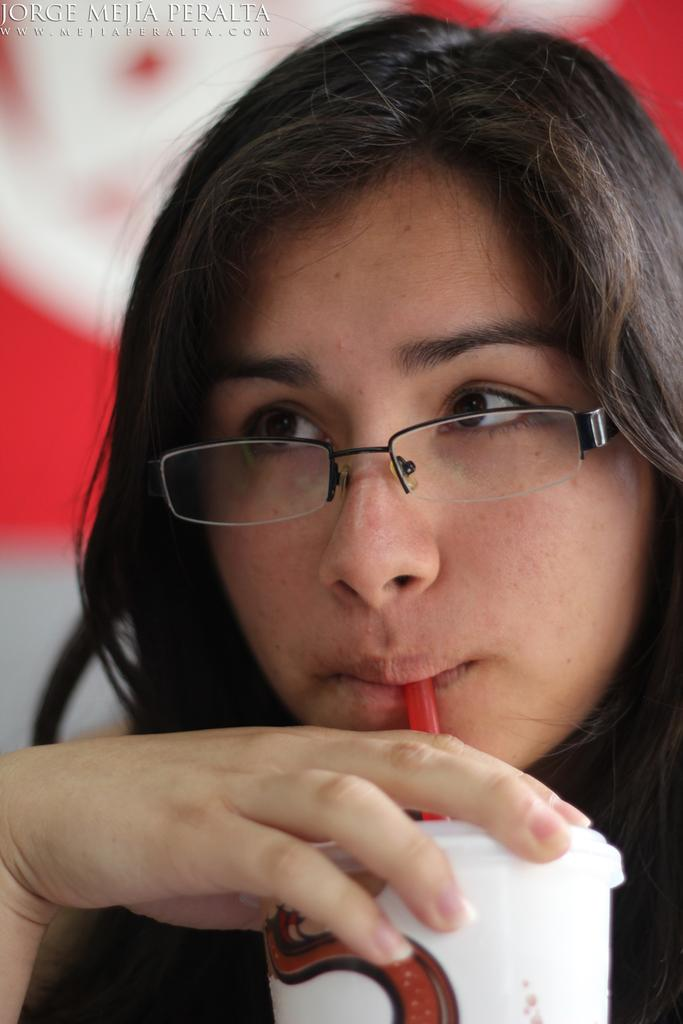What is the main subject of the image? The main subject of the image is a woman. What is the woman doing in the image? The woman is having some liquid in the image. How is the woman consuming the liquid? The liquid is being consumed through a zipper. What can be seen at the top of the image? There is some text visible at the top of the image. How many apples are being used for pleasure in the image? There are no apples or references to pleasure in the image. What type of sign is visible in the image? There is no sign visible in the image; only text at the top can be seen. 